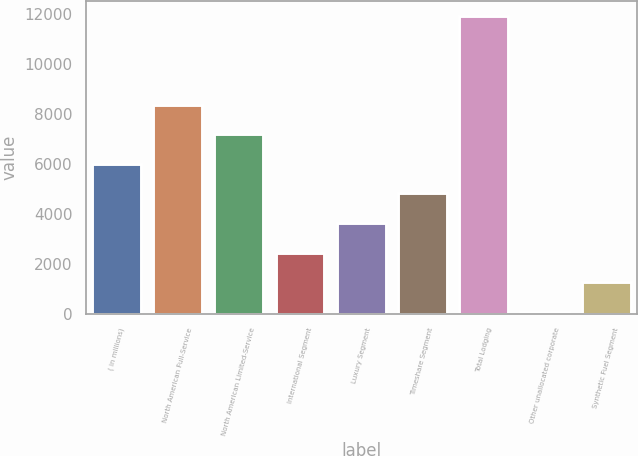<chart> <loc_0><loc_0><loc_500><loc_500><bar_chart><fcel>( in millions)<fcel>North American Full-Service<fcel>North American Limited-Service<fcel>International Segment<fcel>Luxury Segment<fcel>Timeshare Segment<fcel>Total Lodging<fcel>Other unallocated corporate<fcel>Synthetic Fuel Segment<nl><fcel>5997.5<fcel>8370.5<fcel>7184<fcel>2438<fcel>3624.5<fcel>4811<fcel>11930<fcel>65<fcel>1251.5<nl></chart> 